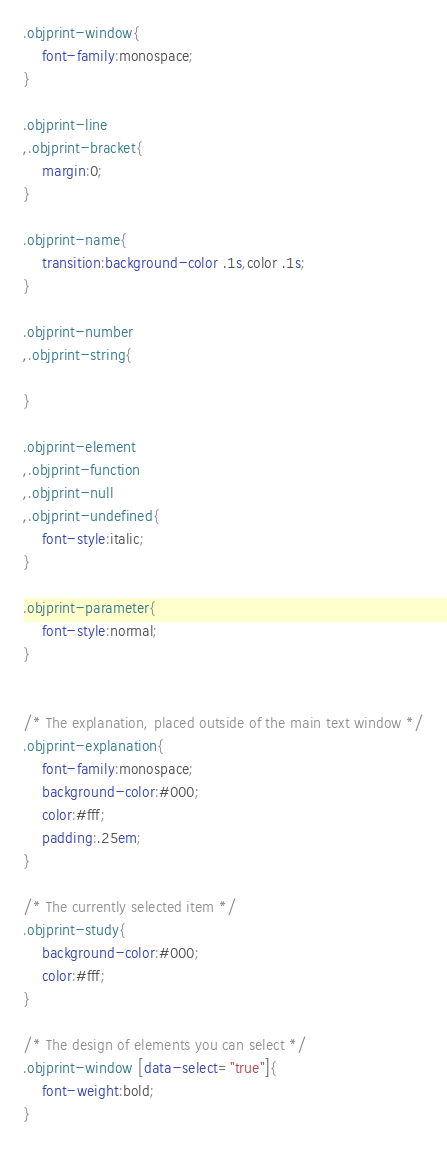Convert code to text. <code><loc_0><loc_0><loc_500><loc_500><_CSS_>.objprint-window{
	font-family:monospace;
}

.objprint-line
,.objprint-bracket{
	margin:0;
}

.objprint-name{
	transition:background-color .1s,color .1s;
}

.objprint-number
,.objprint-string{
	
}

.objprint-element
,.objprint-function
,.objprint-null
,.objprint-undefined{
	font-style:italic;
}

.objprint-parameter{
	font-style:normal;
}


/* The explanation, placed outside of the main text window */
.objprint-explanation{
	font-family:monospace;
	background-color:#000;
	color:#fff;
	padding:.25em;
}

/* The currently selected item */
.objprint-study{
	background-color:#000;
	color:#fff;
}

/* The design of elements you can select */
.objprint-window [data-select="true"]{
	font-weight:bold;
}</code> 